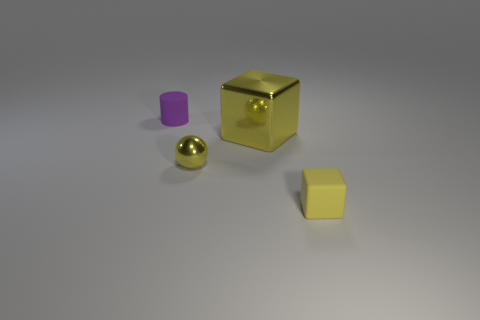Add 1 spheres. How many objects exist? 5 Subtract all spheres. How many objects are left? 3 Add 3 matte objects. How many matte objects exist? 5 Subtract 1 yellow spheres. How many objects are left? 3 Subtract all small balls. Subtract all brown cubes. How many objects are left? 3 Add 4 big shiny blocks. How many big shiny blocks are left? 5 